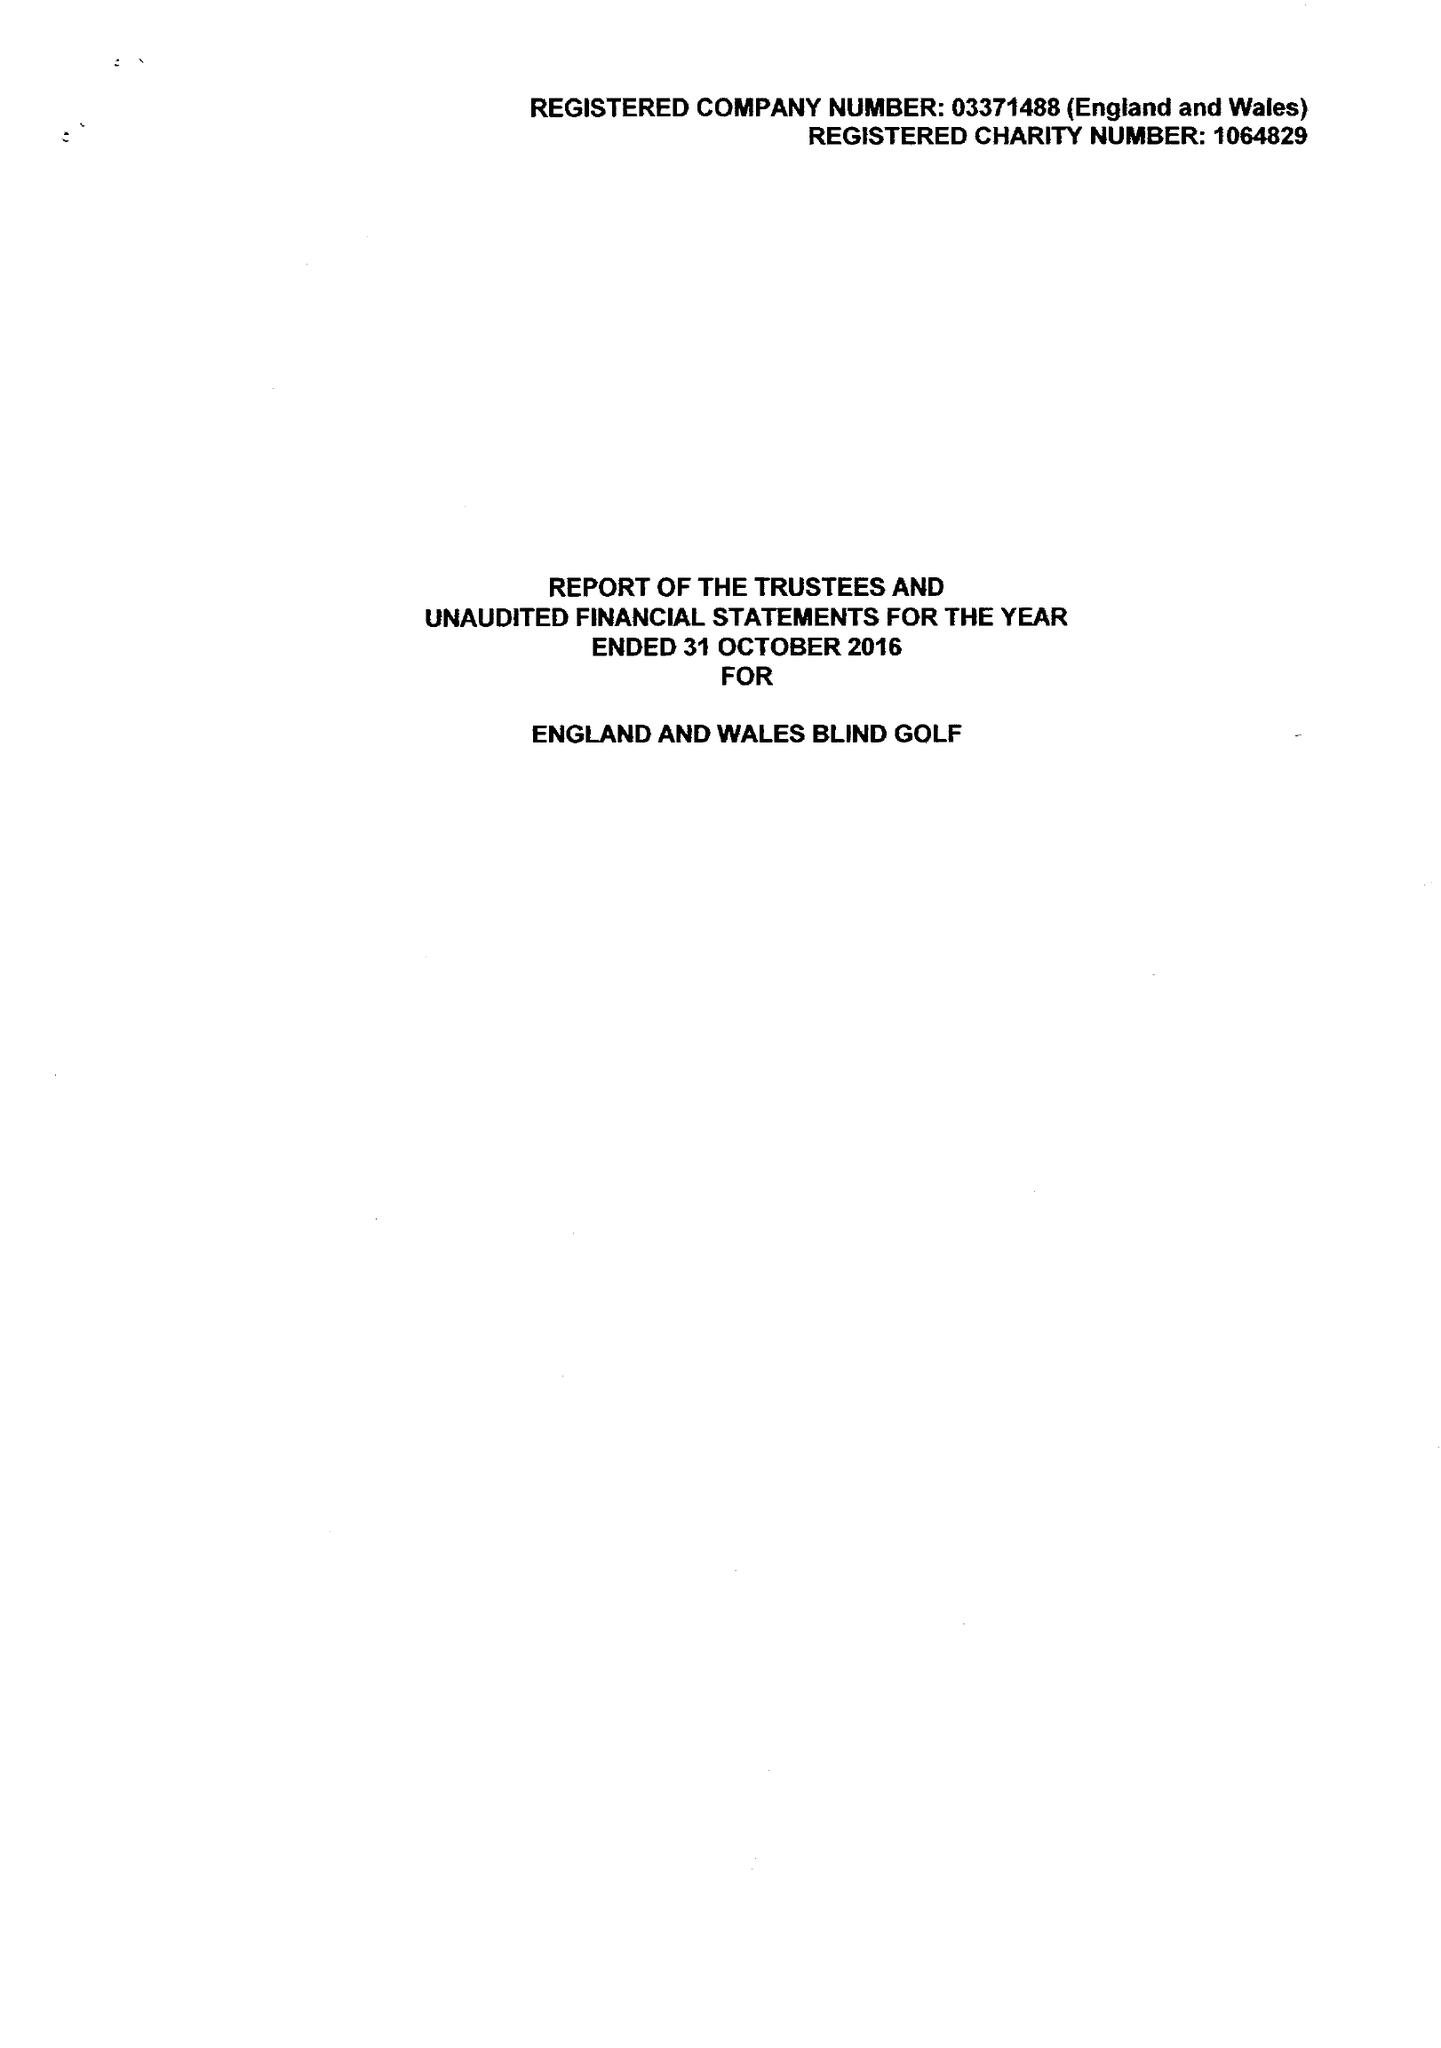What is the value for the charity_number?
Answer the question using a single word or phrase. 1064829 